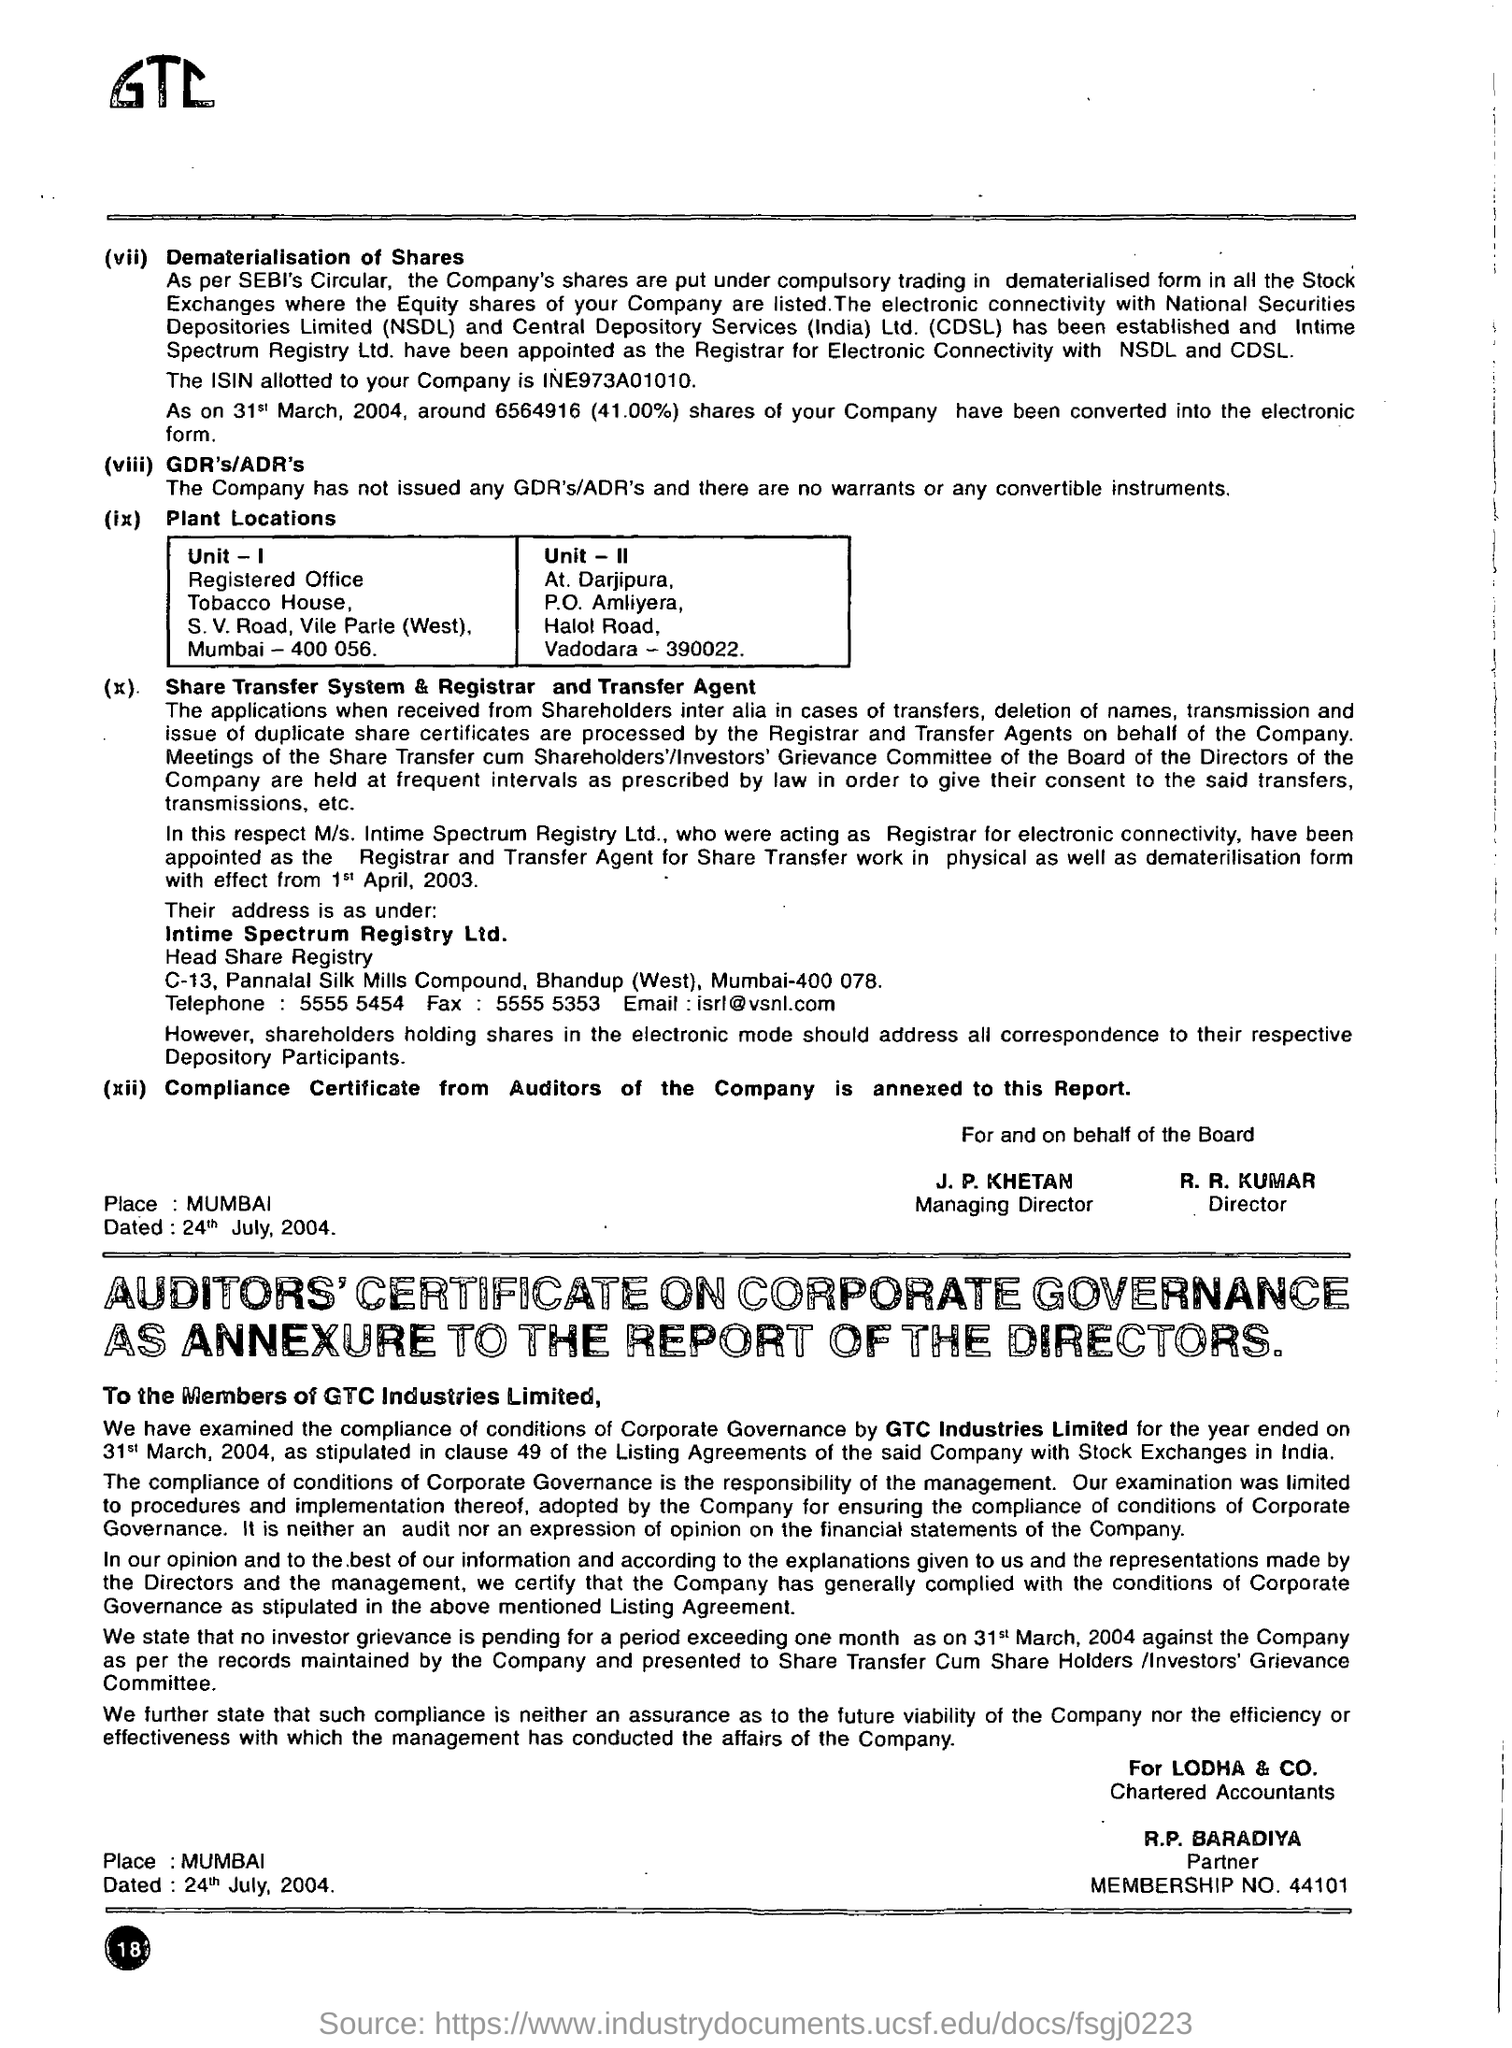what is the name of the company? The company's name is GTC Industries Limited, as clearly stated in the corporate governance report section of the document. 